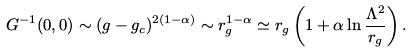Convert formula to latex. <formula><loc_0><loc_0><loc_500><loc_500>G ^ { - 1 } ( 0 , 0 ) \sim ( g - g _ { c } ) ^ { 2 ( 1 - \alpha ) } \sim r _ { g } ^ { 1 - \alpha } \simeq r _ { g } \left ( 1 + \alpha \ln \frac { \Lambda ^ { 2 } } { r _ { g } } \right ) .</formula> 